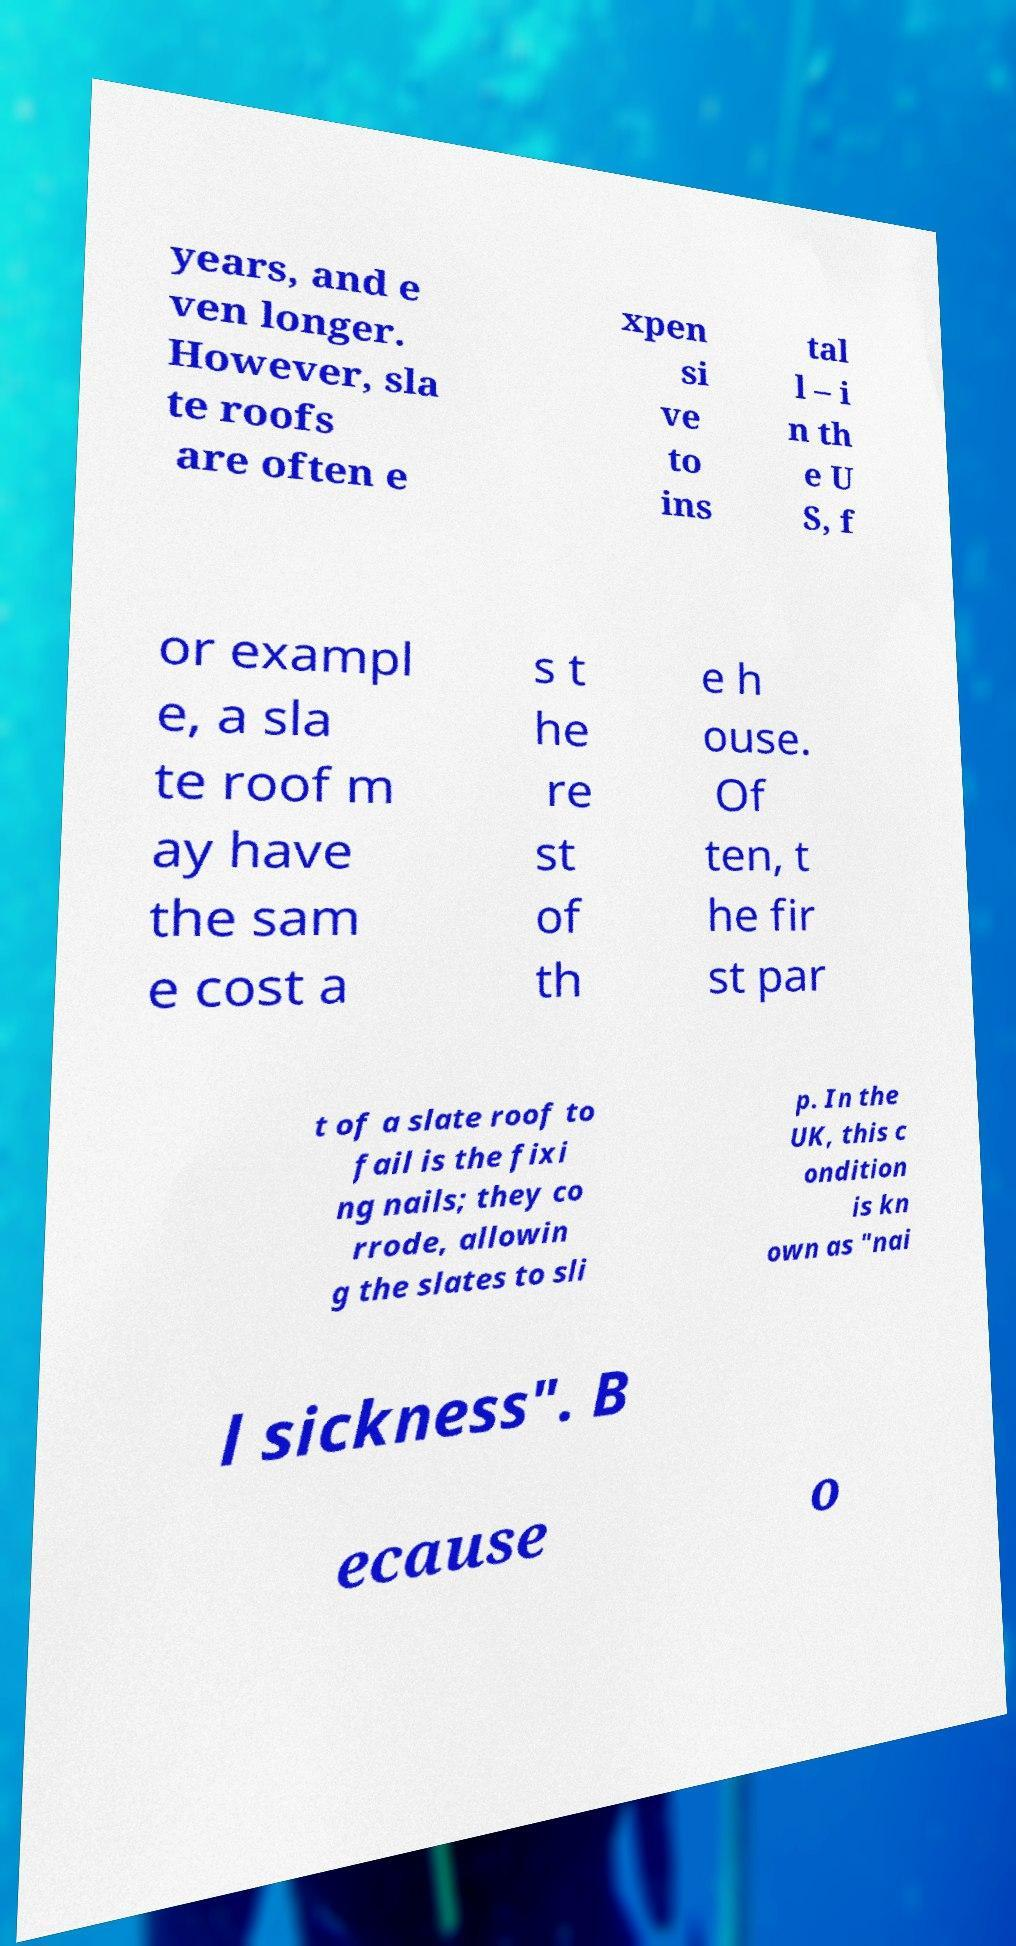Can you accurately transcribe the text from the provided image for me? years, and e ven longer. However, sla te roofs are often e xpen si ve to ins tal l – i n th e U S, f or exampl e, a sla te roof m ay have the sam e cost a s t he re st of th e h ouse. Of ten, t he fir st par t of a slate roof to fail is the fixi ng nails; they co rrode, allowin g the slates to sli p. In the UK, this c ondition is kn own as "nai l sickness". B ecause o 